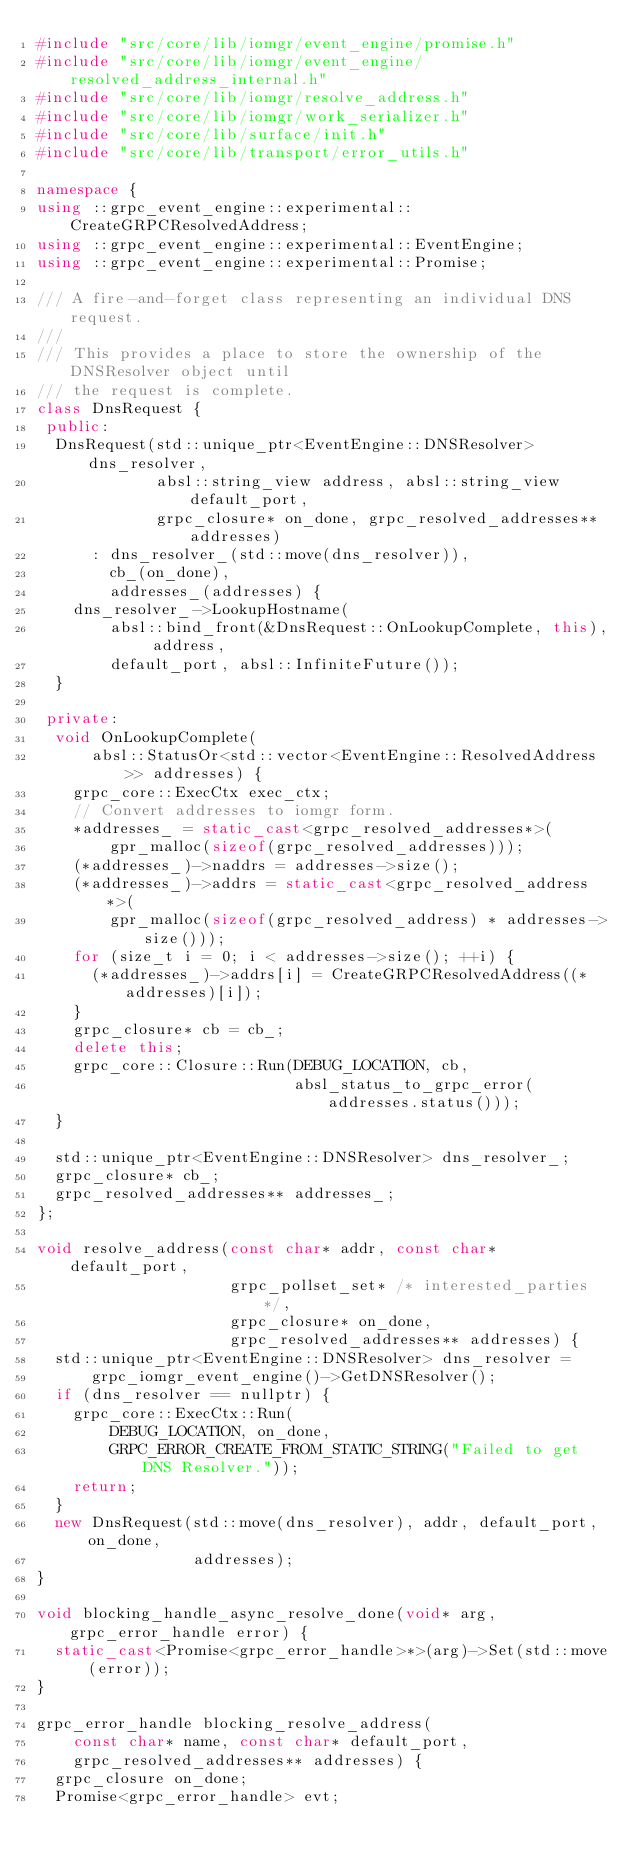<code> <loc_0><loc_0><loc_500><loc_500><_C++_>#include "src/core/lib/iomgr/event_engine/promise.h"
#include "src/core/lib/iomgr/event_engine/resolved_address_internal.h"
#include "src/core/lib/iomgr/resolve_address.h"
#include "src/core/lib/iomgr/work_serializer.h"
#include "src/core/lib/surface/init.h"
#include "src/core/lib/transport/error_utils.h"

namespace {
using ::grpc_event_engine::experimental::CreateGRPCResolvedAddress;
using ::grpc_event_engine::experimental::EventEngine;
using ::grpc_event_engine::experimental::Promise;

/// A fire-and-forget class representing an individual DNS request.
///
/// This provides a place to store the ownership of the DNSResolver object until
/// the request is complete.
class DnsRequest {
 public:
  DnsRequest(std::unique_ptr<EventEngine::DNSResolver> dns_resolver,
             absl::string_view address, absl::string_view default_port,
             grpc_closure* on_done, grpc_resolved_addresses** addresses)
      : dns_resolver_(std::move(dns_resolver)),
        cb_(on_done),
        addresses_(addresses) {
    dns_resolver_->LookupHostname(
        absl::bind_front(&DnsRequest::OnLookupComplete, this), address,
        default_port, absl::InfiniteFuture());
  }

 private:
  void OnLookupComplete(
      absl::StatusOr<std::vector<EventEngine::ResolvedAddress>> addresses) {
    grpc_core::ExecCtx exec_ctx;
    // Convert addresses to iomgr form.
    *addresses_ = static_cast<grpc_resolved_addresses*>(
        gpr_malloc(sizeof(grpc_resolved_addresses)));
    (*addresses_)->naddrs = addresses->size();
    (*addresses_)->addrs = static_cast<grpc_resolved_address*>(
        gpr_malloc(sizeof(grpc_resolved_address) * addresses->size()));
    for (size_t i = 0; i < addresses->size(); ++i) {
      (*addresses_)->addrs[i] = CreateGRPCResolvedAddress((*addresses)[i]);
    }
    grpc_closure* cb = cb_;
    delete this;
    grpc_core::Closure::Run(DEBUG_LOCATION, cb,
                            absl_status_to_grpc_error(addresses.status()));
  }

  std::unique_ptr<EventEngine::DNSResolver> dns_resolver_;
  grpc_closure* cb_;
  grpc_resolved_addresses** addresses_;
};

void resolve_address(const char* addr, const char* default_port,
                     grpc_pollset_set* /* interested_parties */,
                     grpc_closure* on_done,
                     grpc_resolved_addresses** addresses) {
  std::unique_ptr<EventEngine::DNSResolver> dns_resolver =
      grpc_iomgr_event_engine()->GetDNSResolver();
  if (dns_resolver == nullptr) {
    grpc_core::ExecCtx::Run(
        DEBUG_LOCATION, on_done,
        GRPC_ERROR_CREATE_FROM_STATIC_STRING("Failed to get DNS Resolver."));
    return;
  }
  new DnsRequest(std::move(dns_resolver), addr, default_port, on_done,
                 addresses);
}

void blocking_handle_async_resolve_done(void* arg, grpc_error_handle error) {
  static_cast<Promise<grpc_error_handle>*>(arg)->Set(std::move(error));
}

grpc_error_handle blocking_resolve_address(
    const char* name, const char* default_port,
    grpc_resolved_addresses** addresses) {
  grpc_closure on_done;
  Promise<grpc_error_handle> evt;</code> 